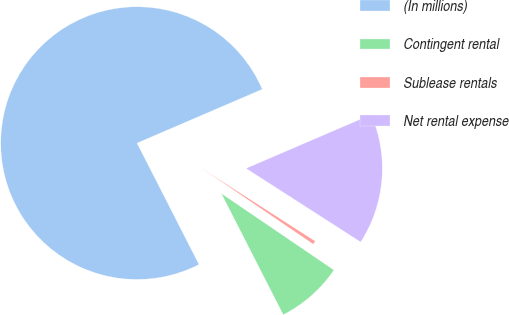<chart> <loc_0><loc_0><loc_500><loc_500><pie_chart><fcel>(In millions)<fcel>Contingent rental<fcel>Sublease rentals<fcel>Net rental expense<nl><fcel>76.06%<fcel>7.98%<fcel>0.42%<fcel>15.55%<nl></chart> 